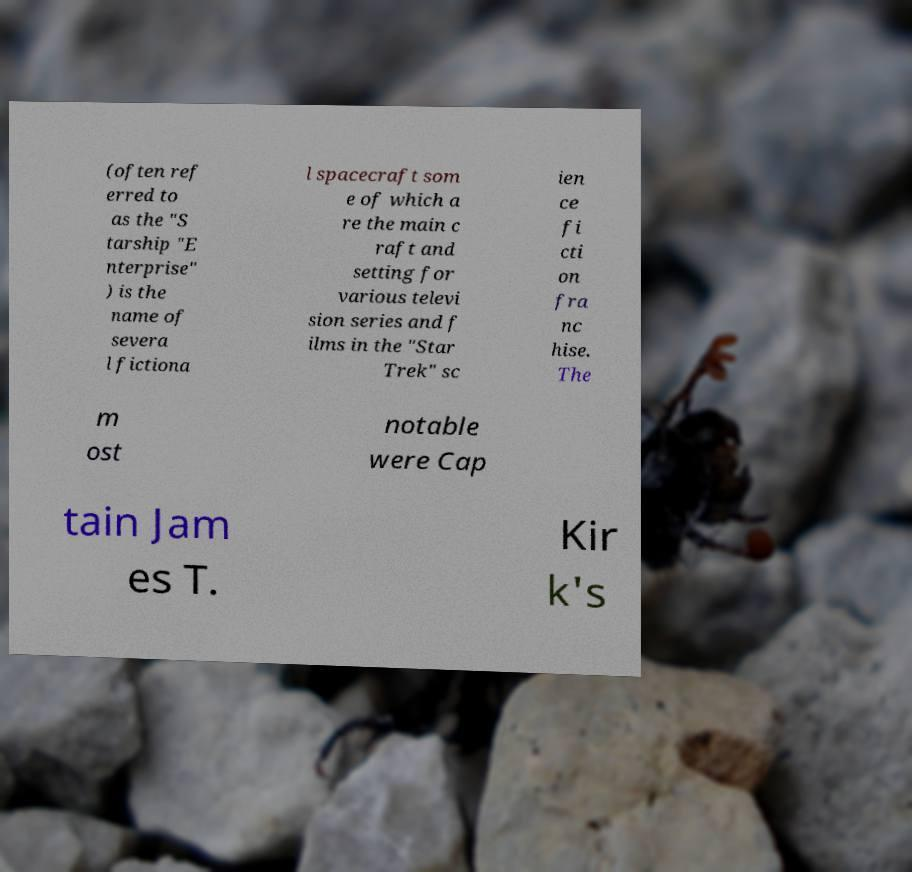Could you assist in decoding the text presented in this image and type it out clearly? (often ref erred to as the "S tarship "E nterprise" ) is the name of severa l fictiona l spacecraft som e of which a re the main c raft and setting for various televi sion series and f ilms in the "Star Trek" sc ien ce fi cti on fra nc hise. The m ost notable were Cap tain Jam es T. Kir k's 